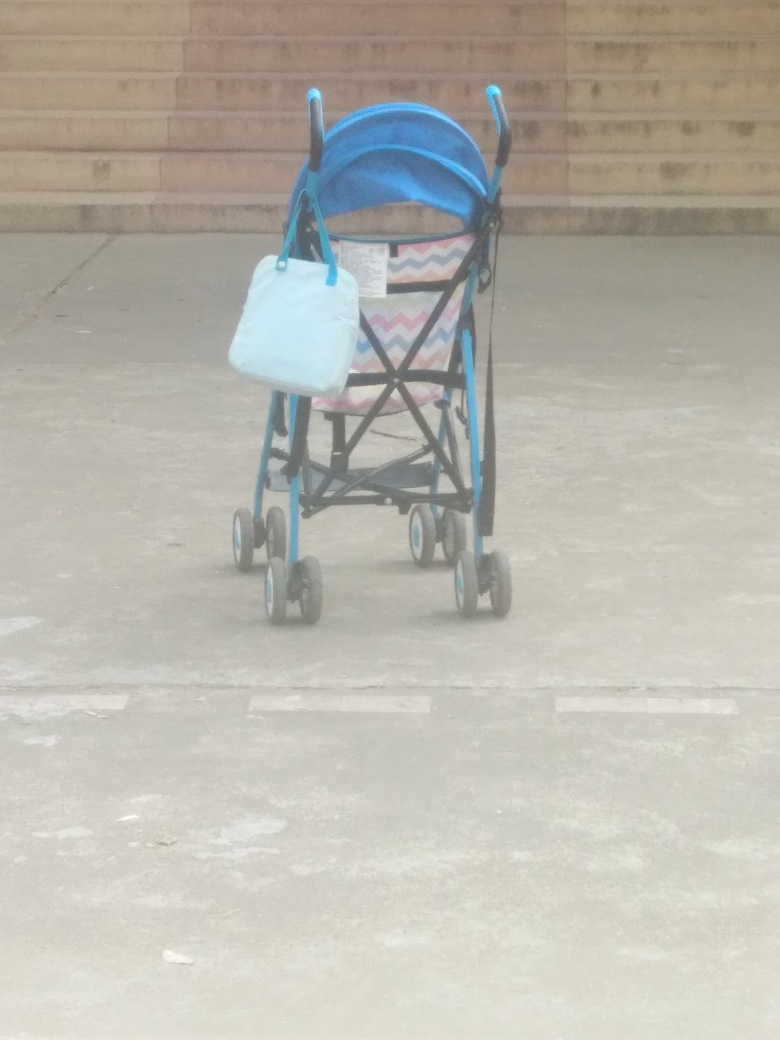Can you tell me more about the design of the stroller in the image? This stroller features a compact design, with a colorful, geometric pattern on the seat and a vivid blue canopy providing shade. The frame appears to be constructed from lightweight metal, ideal for easy transportation. Small wheels are equipped for maneuverability, though they might not be suited for rough terrain. The attached bag indicates the stroller also serves a functional role for carrying items. Is there any indication of the time of day or weather when this photo was taken? The presence of shadows and the overall lighting suggests that the photo was taken during the daytime. The weather appears to be fair, as the ground does not seem wet, and there's ample daylight illuminating the scene. The outdoor setting and clarity of light could imply that it's a sunny or at least a bright cloudy day. 